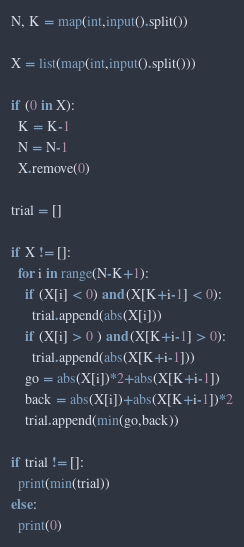<code> <loc_0><loc_0><loc_500><loc_500><_Python_>N, K = map(int,input().split())

X = list(map(int,input().split()))

if (0 in X):
  K = K-1
  N = N-1
  X.remove(0)

trial = []

if X != []:
  for i in range(N-K+1):
    if (X[i] < 0) and (X[K+i-1] < 0):
      trial.append(abs(X[i]))
    if (X[i] > 0 ) and (X[K+i-1] > 0):
      trial.append(abs(X[K+i-1]))
    go = abs(X[i])*2+abs(X[K+i-1])
    back = abs(X[i])+abs(X[K+i-1])*2
    trial.append(min(go,back))
  
if trial != []:
  print(min(trial))
else:
  print(0)</code> 